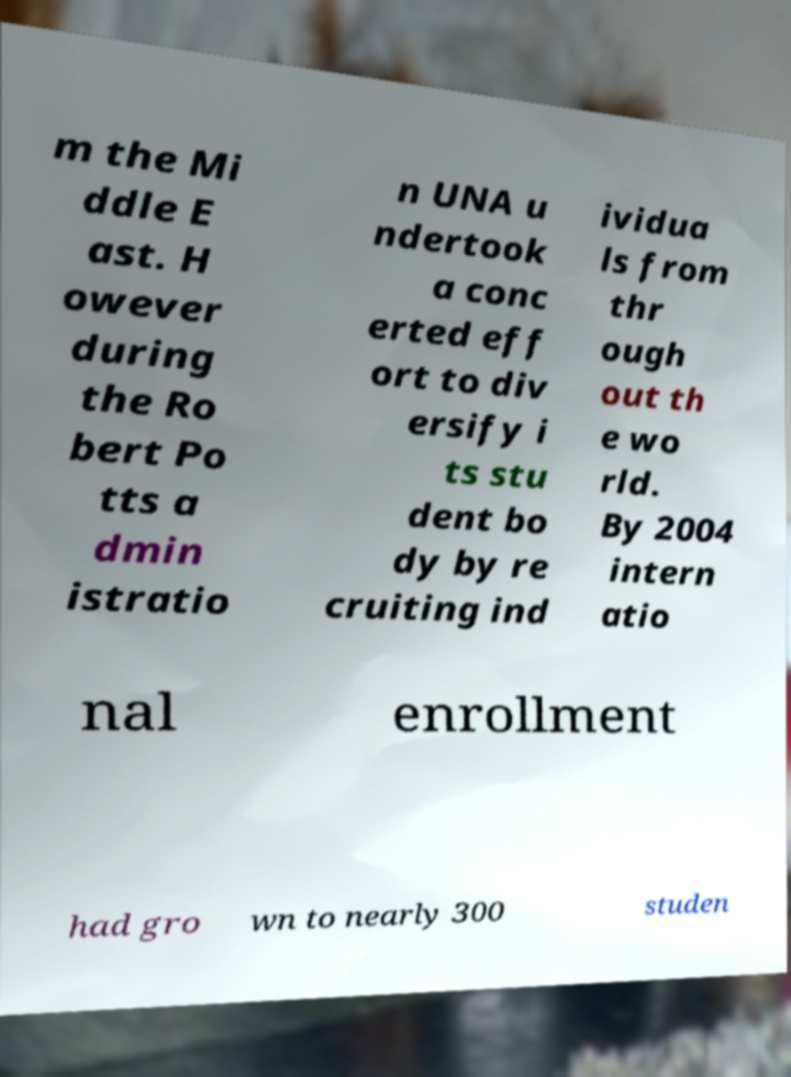What messages or text are displayed in this image? I need them in a readable, typed format. m the Mi ddle E ast. H owever during the Ro bert Po tts a dmin istratio n UNA u ndertook a conc erted eff ort to div ersify i ts stu dent bo dy by re cruiting ind ividua ls from thr ough out th e wo rld. By 2004 intern atio nal enrollment had gro wn to nearly 300 studen 